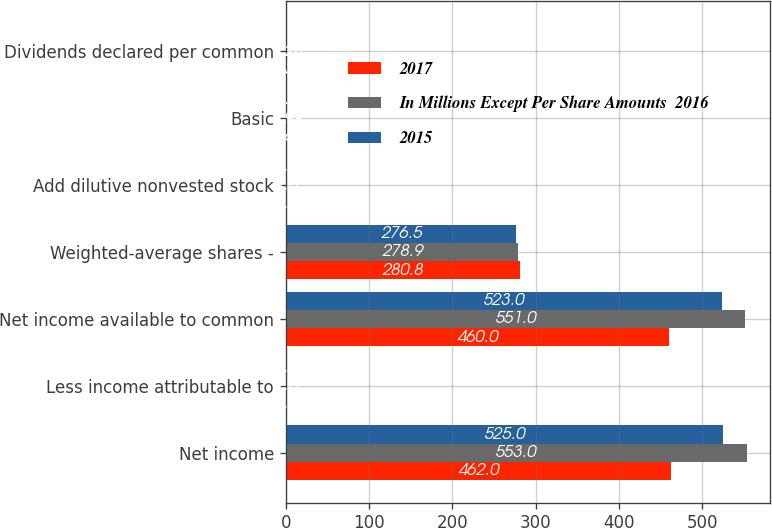Convert chart to OTSL. <chart><loc_0><loc_0><loc_500><loc_500><stacked_bar_chart><ecel><fcel>Net income<fcel>Less income attributable to<fcel>Net income available to common<fcel>Weighted-average shares -<fcel>Add dilutive nonvested stock<fcel>Basic<fcel>Dividends declared per common<nl><fcel>2017<fcel>462<fcel>2<fcel>460<fcel>280.8<fcel>0.8<fcel>1.64<fcel>1.33<nl><fcel>In Millions Except Per Share Amounts  2016<fcel>553<fcel>2<fcel>551<fcel>278.9<fcel>1<fcel>1.99<fcel>1.24<nl><fcel>2015<fcel>525<fcel>2<fcel>523<fcel>276.5<fcel>0.9<fcel>1.9<fcel>1.16<nl></chart> 